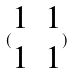Convert formula to latex. <formula><loc_0><loc_0><loc_500><loc_500>( \begin{matrix} 1 & 1 \\ 1 & 1 \end{matrix} )</formula> 